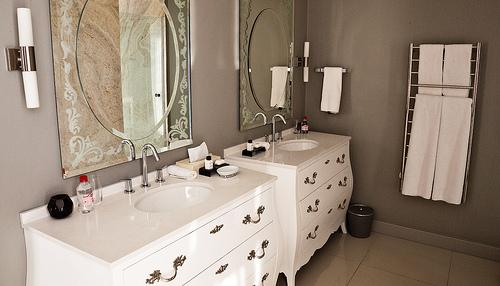Write a short story using the objects in the image as characters. Once upon a time in a bright and cheerful bathroom, the Faucet Twins, joined by Mirror Siblings, and the gossiping Towel Gang watched as their dear friend Trash Can maintained cleanliness and order throughout their shared space. Mention the primary objects found in this image along with their colors. Silver faucets, red bottle cap, large oval mirror, white wall lamp, silver drawer handle, white Kleenex tissues, white hanging towels, black trash bin, tiled floor. Describe the theme and atmosphere in the picture. A well-lit modern bathroom with tiled floors and efficiently placed amenities like sinks, faucets, soap dish, tissue box, towel rack, and a trash bin. Briefly describe the main elements you see in the image. A bathroom with two sinks, faucets, oval mirrors, a light fixture, a towel rack with white towels, a soap dish, tissue box, and a small trash can. Pick any three objects from the image and give a short description of them. A white soap dish on the counter, silver towel holder with white towels hanging, and a small dark-colored waste bin on the tiled floor. Mention the most prominent features of the room and their colors. Silver faucets over sinks, white hanging towels on silver towel rack, black trash can on tiled floor, white lamp on wall, and kleenex tissues in a box. Imagine you are entering this room, describe what you would notice first and why. Upon entering the room, the two sinks and faucets under the large oval mirrors would be the first to catch one's attention as they create a sense of symmetry and highlight the functional aspect of the bathroom. Imagine you are describing this image to a visually impaired person, paint a detailed picture of it. A cozy bathroom scene featuring two matching sinks with silver faucets above them, large oval mirrors on the wall, a white lamp next to each mirror, a silver towel rack holding neatly folded white towels, a white soap dish, and a black trash can on the tiled floor.  What are the main functions the items in this image fulfill? Sink and faucet for washing, mirrors for grooming, towels for drying, tissue box for hygiene, soap dish for storing soap, and trash can for waste disposal. Write a single sentence that captures the essence of the image. The bright and airy-feel bathroom features dual sinks with faucets, a towel rack with fluffy white towels, a cute soap dish, and a black trash can on neatly laid tiles.  